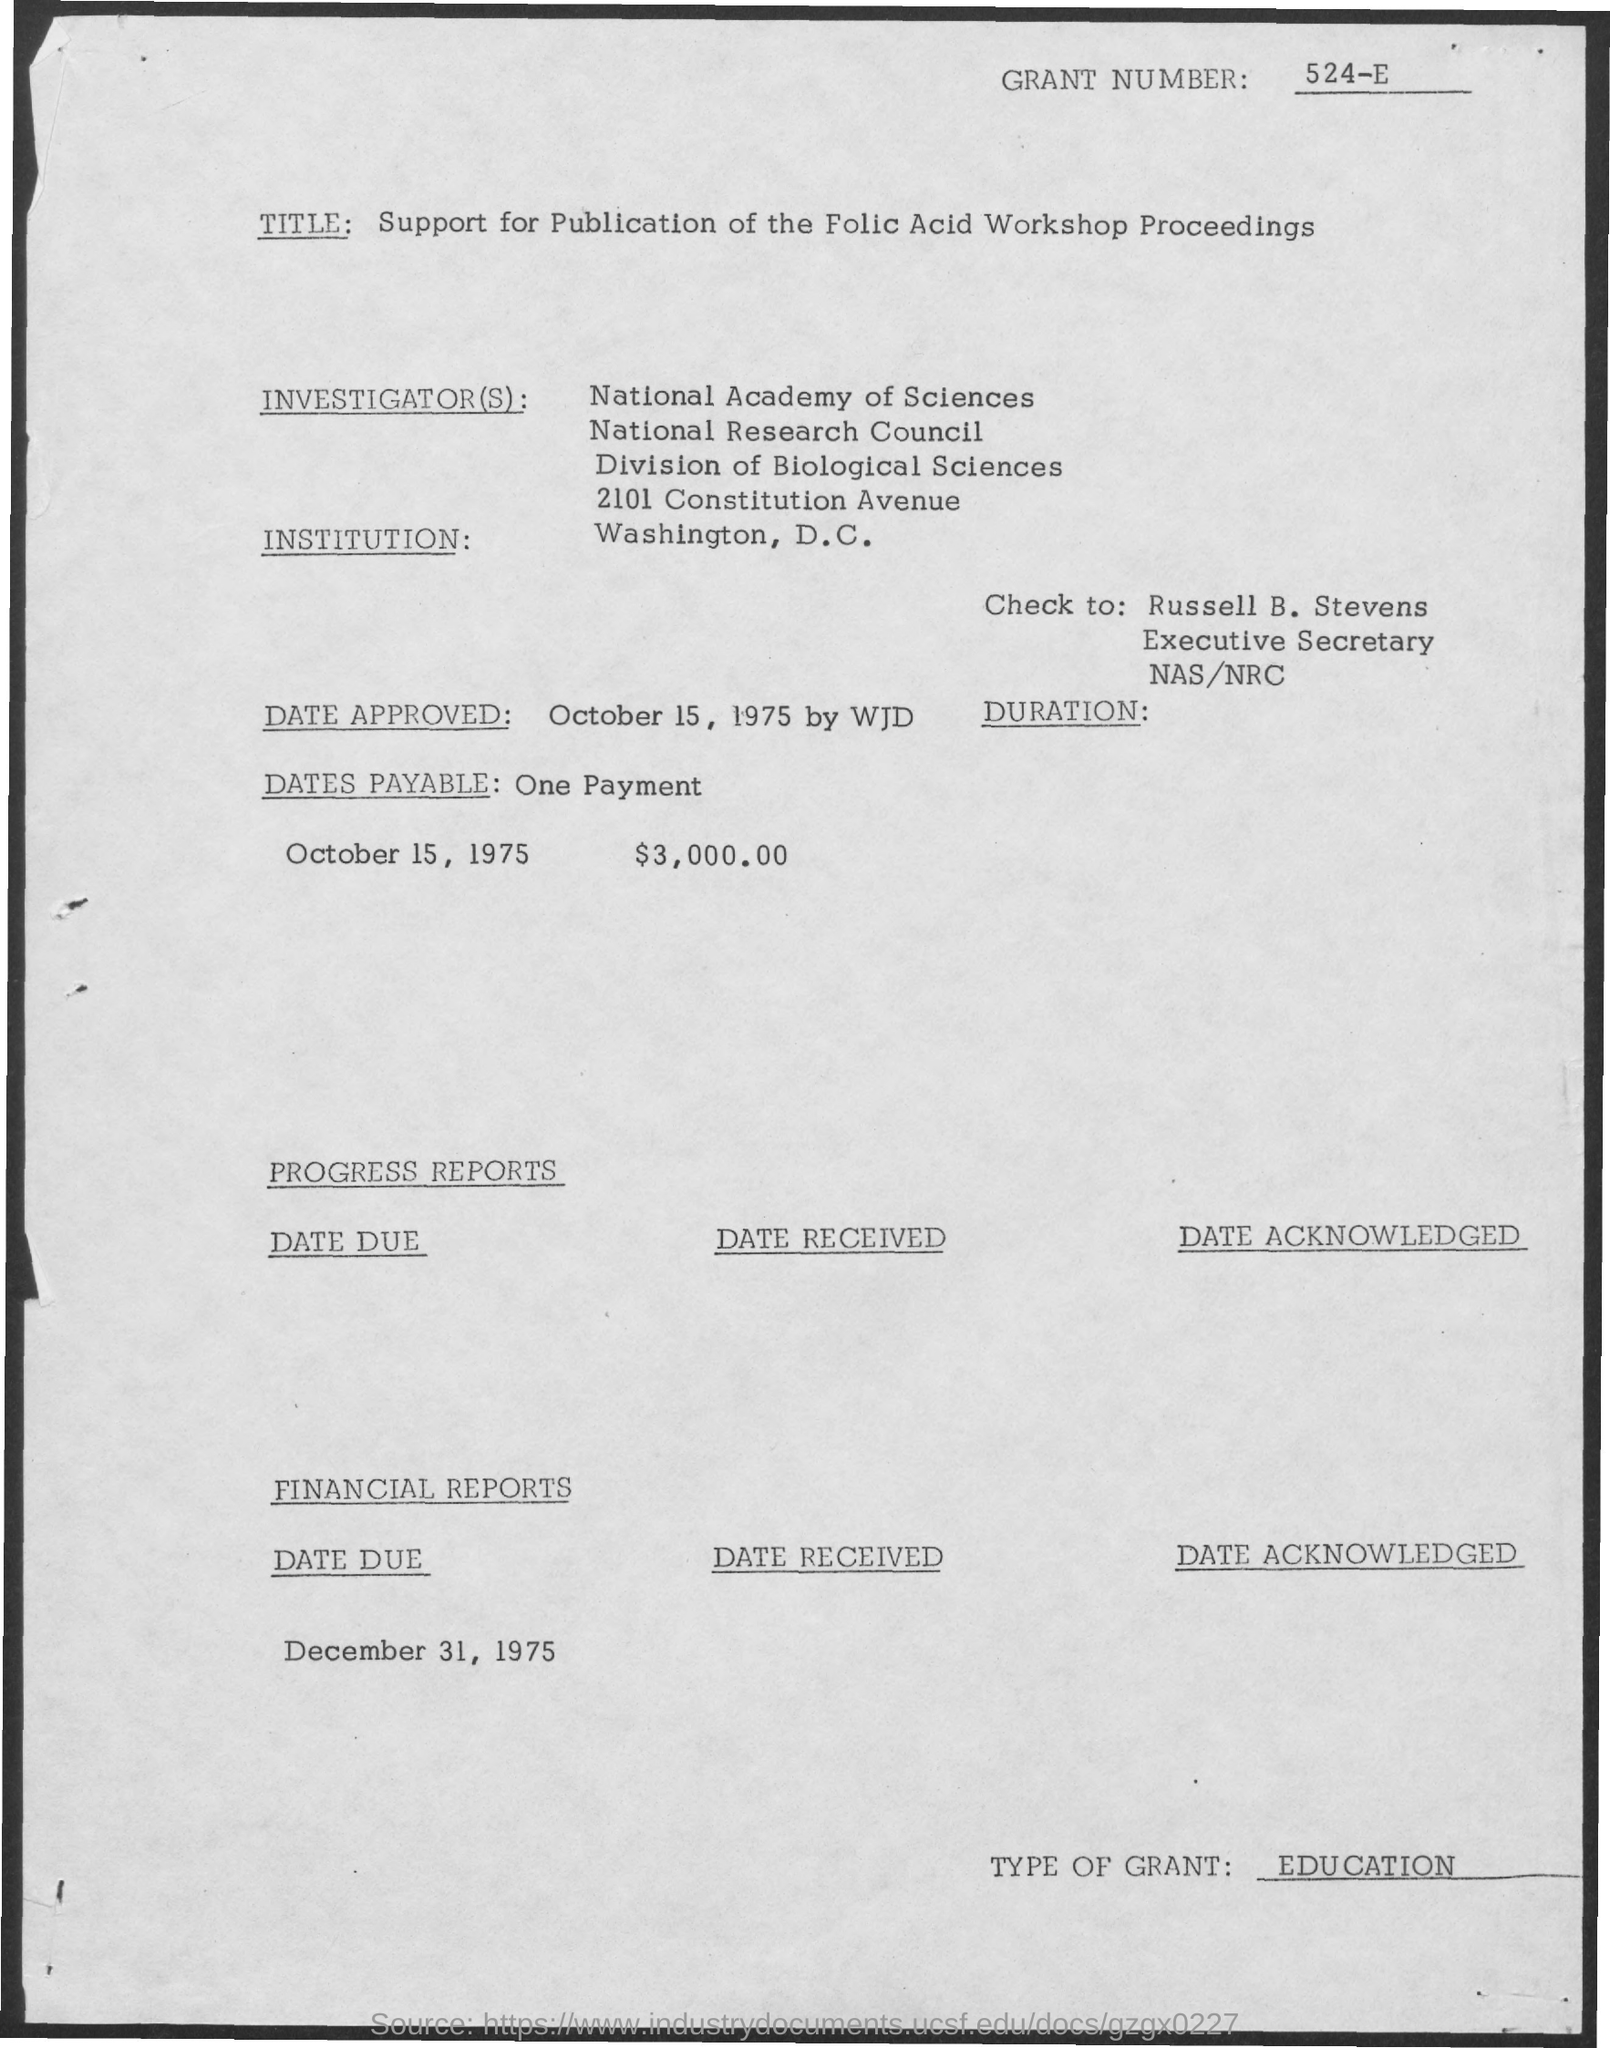Give some essential details in this illustration. What is the Dates Payable? It is a single payment that... The date due is December 31, 1975. The check is made payable to Russell B. Stevens. 